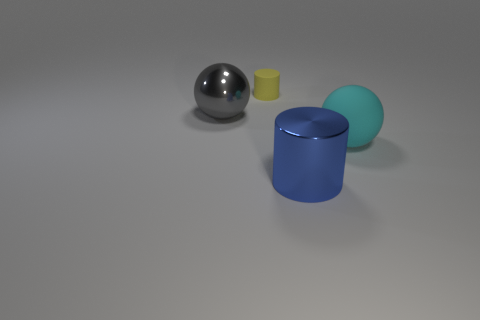What is the material of the small object?
Provide a short and direct response. Rubber. There is a cylinder that is the same size as the cyan sphere; what is its color?
Keep it short and to the point. Blue. Do the yellow rubber object and the blue metallic object have the same shape?
Your answer should be very brief. Yes. There is a thing that is behind the blue thing and in front of the large gray metal object; what is its material?
Provide a succinct answer. Rubber. The matte cylinder has what size?
Provide a short and direct response. Small. There is a shiny object that is the same shape as the cyan matte object; what is its color?
Offer a very short reply. Gray. Are there any other things that are the same color as the tiny matte cylinder?
Offer a very short reply. No. Is the size of the sphere that is to the right of the small cylinder the same as the rubber object left of the large shiny cylinder?
Make the answer very short. No. Is the number of rubber balls that are on the left side of the big cyan matte ball the same as the number of tiny yellow matte cylinders in front of the large cylinder?
Give a very brief answer. Yes. Does the blue thing have the same size as the cylinder that is behind the cyan sphere?
Your response must be concise. No. 